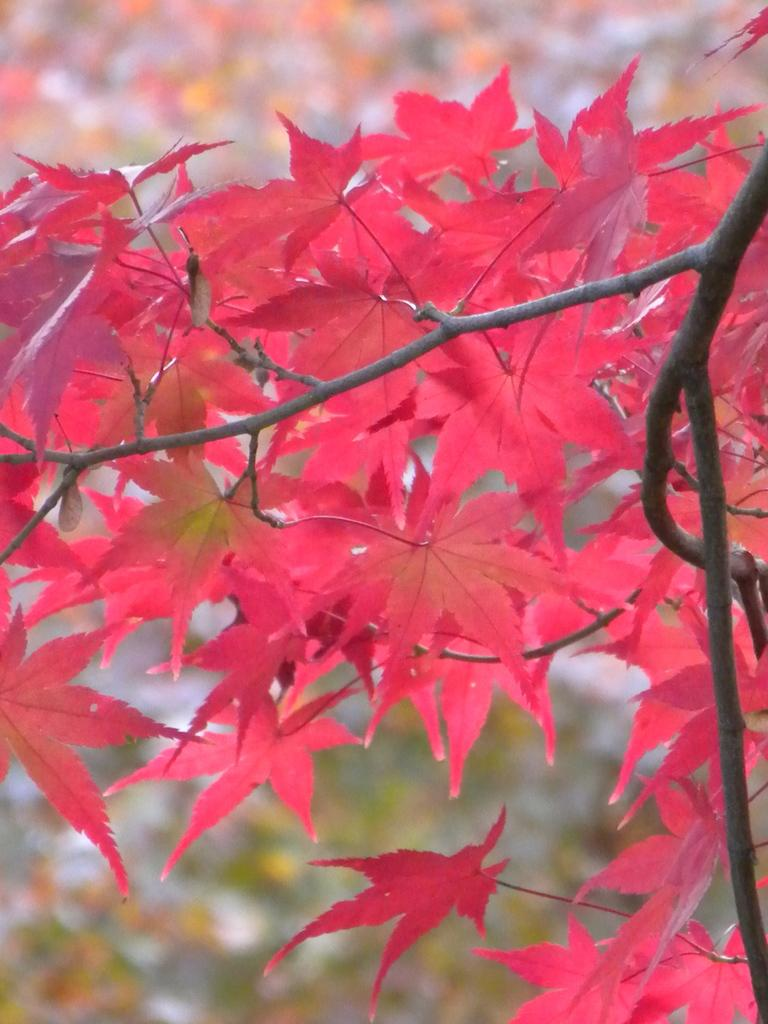What is the main subject of the image? There is a plant in the image. What specific part of the plant can be seen? There are leaves on the plant. Can you describe the background of the image? The background of the image is blurred. What type of boot is visible in the image? There is no boot present in the image; it features a plant with leaves. How many servants can be seen attending to the plant in the image? There are no servants present in the image; it only shows a plant with leaves and a blurred background. 